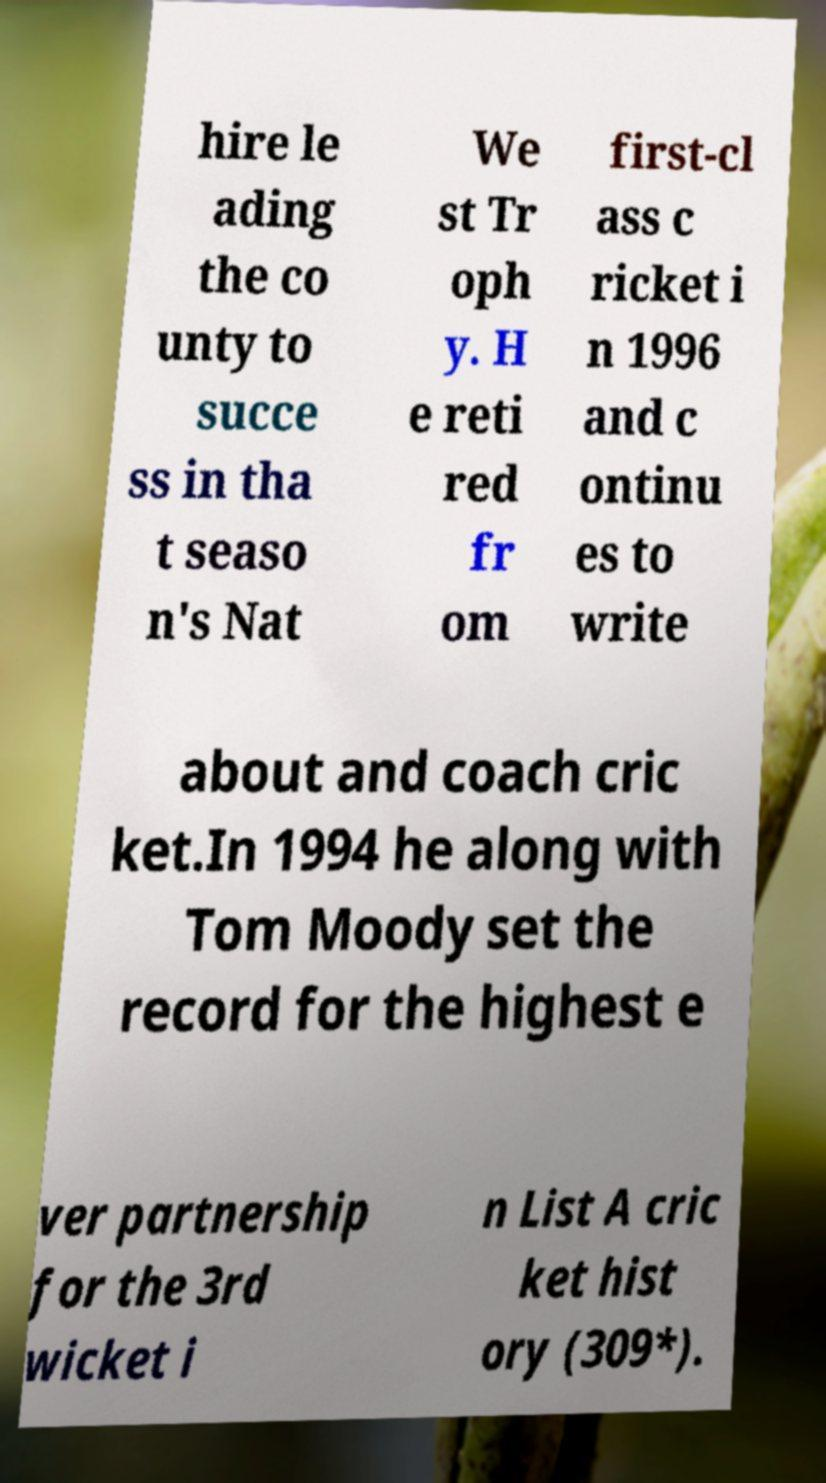Please read and relay the text visible in this image. What does it say? hire le ading the co unty to succe ss in tha t seaso n's Nat We st Tr oph y. H e reti red fr om first-cl ass c ricket i n 1996 and c ontinu es to write about and coach cric ket.In 1994 he along with Tom Moody set the record for the highest e ver partnership for the 3rd wicket i n List A cric ket hist ory (309*). 